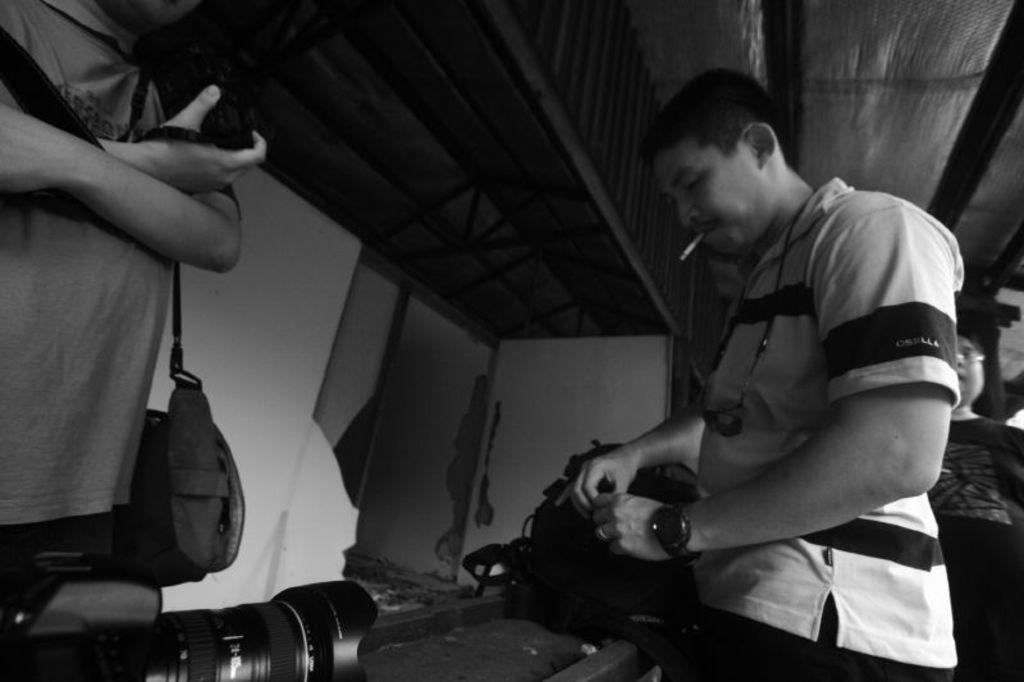How would you summarize this image in a sentence or two? This is a black and white picture. In this picture we can see a man, smoking a cigarette and he is standing. it seems like he is holding something. We can see a camera place on the platform. On the left side of the picture we can see a man standing and he is carrying a bag. In the background we can see the mirror, cloth, wall and at the top we can see the ceiling. On the right side of the picture we can see a woman wearing spectacles. 